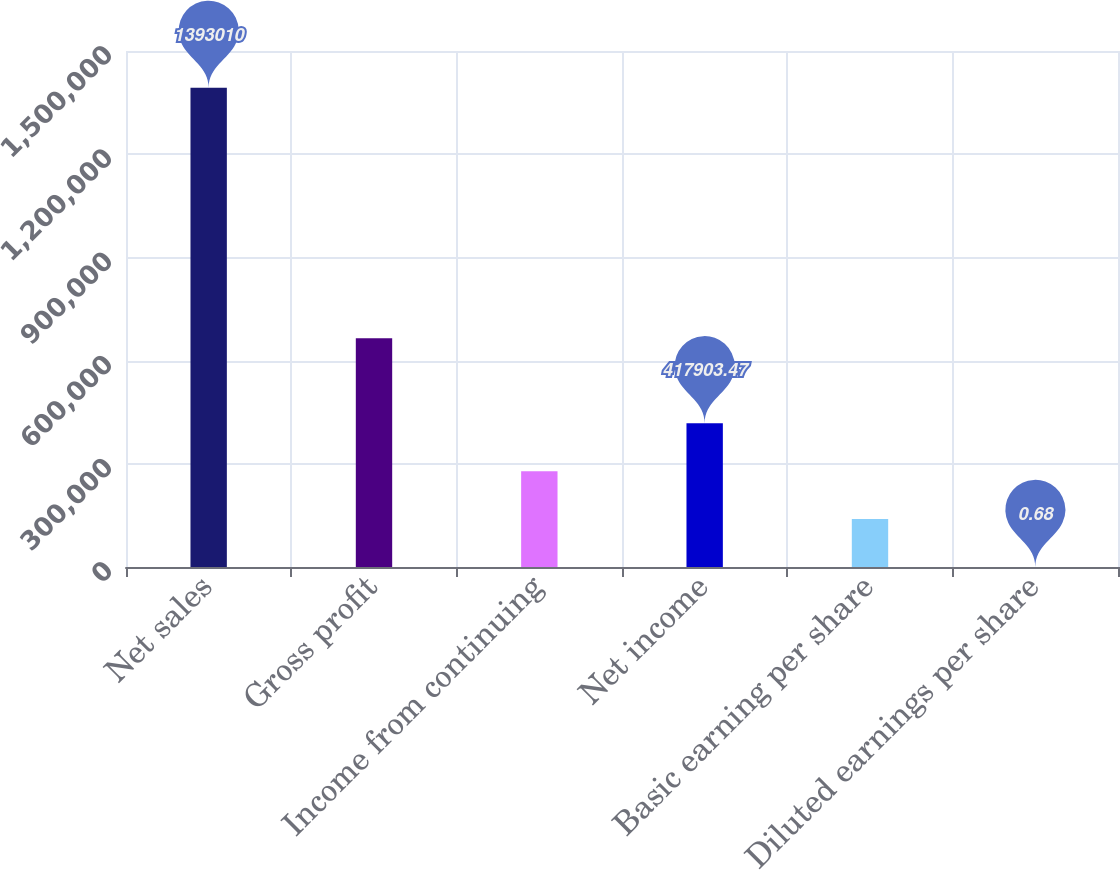<chart> <loc_0><loc_0><loc_500><loc_500><bar_chart><fcel>Net sales<fcel>Gross profit<fcel>Income from continuing<fcel>Net income<fcel>Basic earning per share<fcel>Diluted earnings per share<nl><fcel>1.39301e+06<fcel>665168<fcel>278603<fcel>417903<fcel>139302<fcel>0.68<nl></chart> 